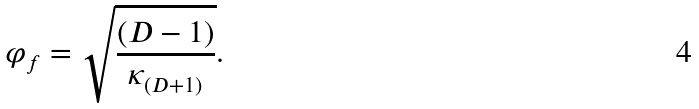<formula> <loc_0><loc_0><loc_500><loc_500>\varphi _ { f } = \sqrt { \frac { ( D - 1 ) } { \kappa _ { ( D + 1 ) } } } .</formula> 